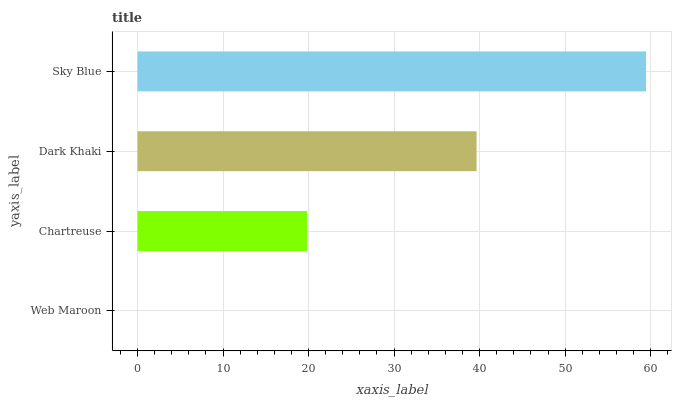Is Web Maroon the minimum?
Answer yes or no. Yes. Is Sky Blue the maximum?
Answer yes or no. Yes. Is Chartreuse the minimum?
Answer yes or no. No. Is Chartreuse the maximum?
Answer yes or no. No. Is Chartreuse greater than Web Maroon?
Answer yes or no. Yes. Is Web Maroon less than Chartreuse?
Answer yes or no. Yes. Is Web Maroon greater than Chartreuse?
Answer yes or no. No. Is Chartreuse less than Web Maroon?
Answer yes or no. No. Is Dark Khaki the high median?
Answer yes or no. Yes. Is Chartreuse the low median?
Answer yes or no. Yes. Is Sky Blue the high median?
Answer yes or no. No. Is Web Maroon the low median?
Answer yes or no. No. 